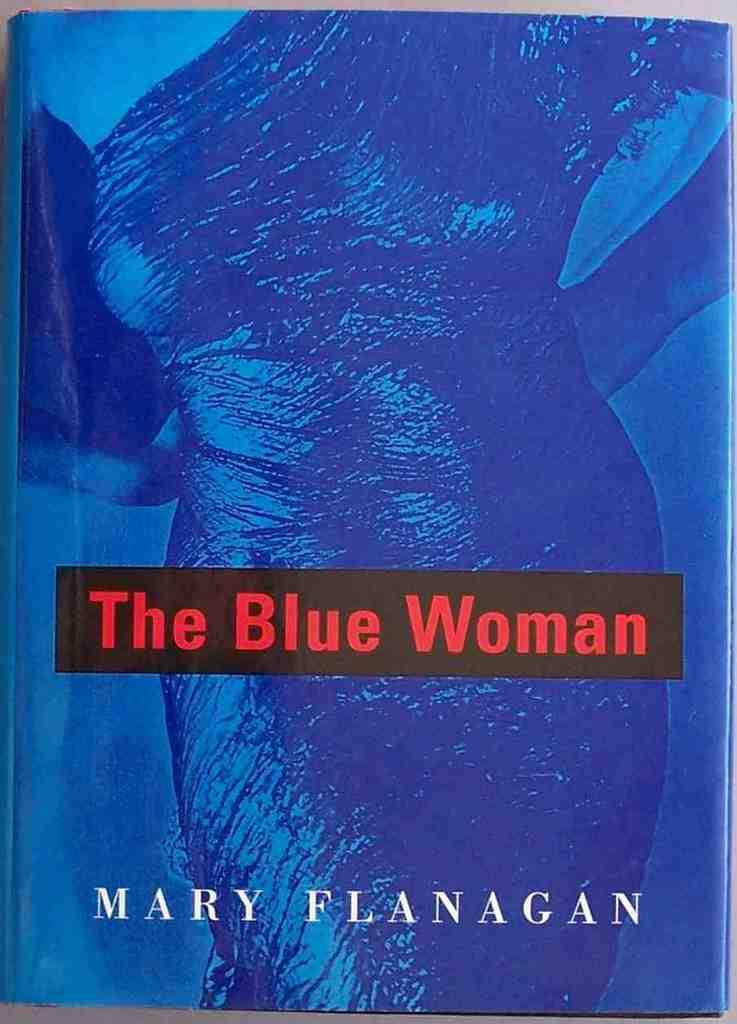<image>
Summarize the visual content of the image. A blue covered by with the title The Blue Woman. 